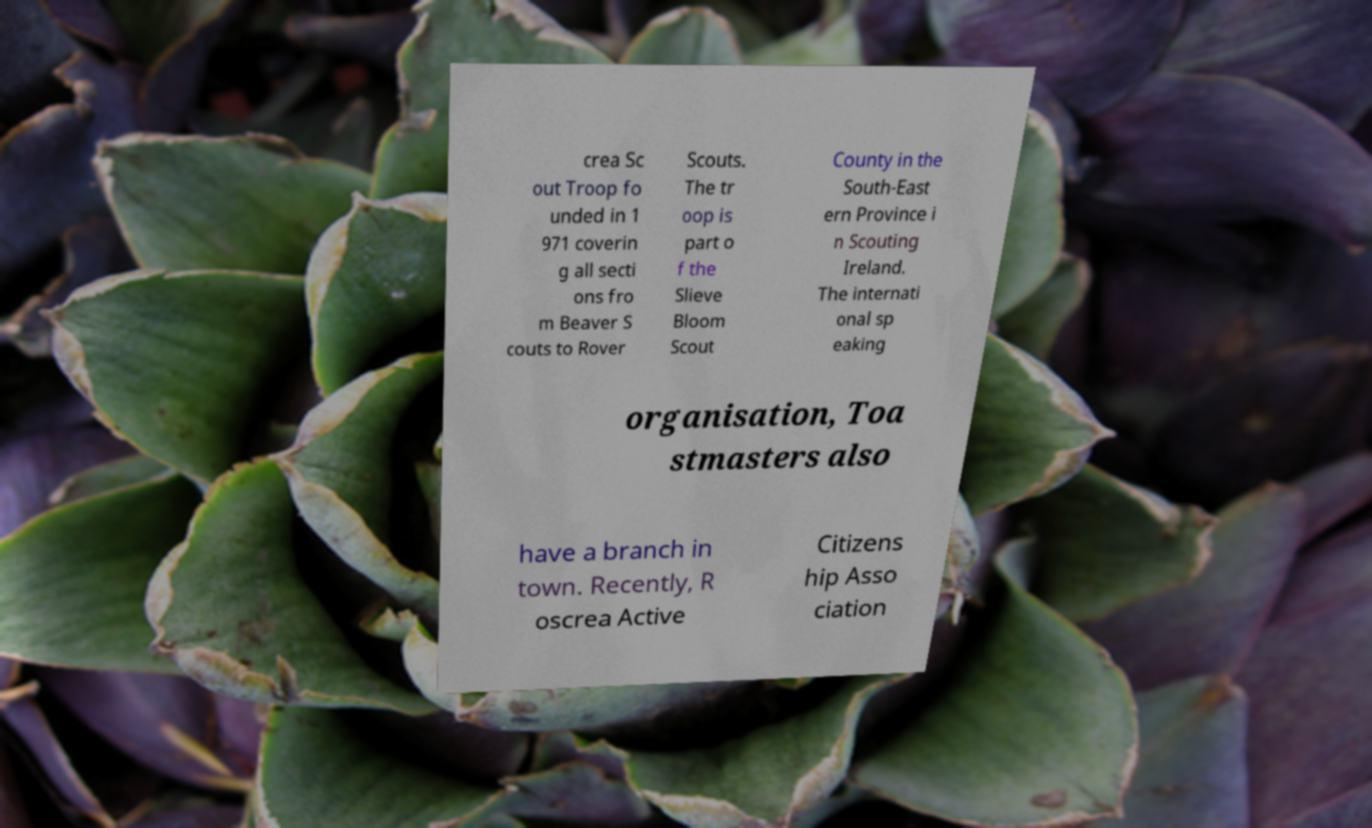What messages or text are displayed in this image? I need them in a readable, typed format. crea Sc out Troop fo unded in 1 971 coverin g all secti ons fro m Beaver S couts to Rover Scouts. The tr oop is part o f the Slieve Bloom Scout County in the South-East ern Province i n Scouting Ireland. The internati onal sp eaking organisation, Toa stmasters also have a branch in town. Recently, R oscrea Active Citizens hip Asso ciation 